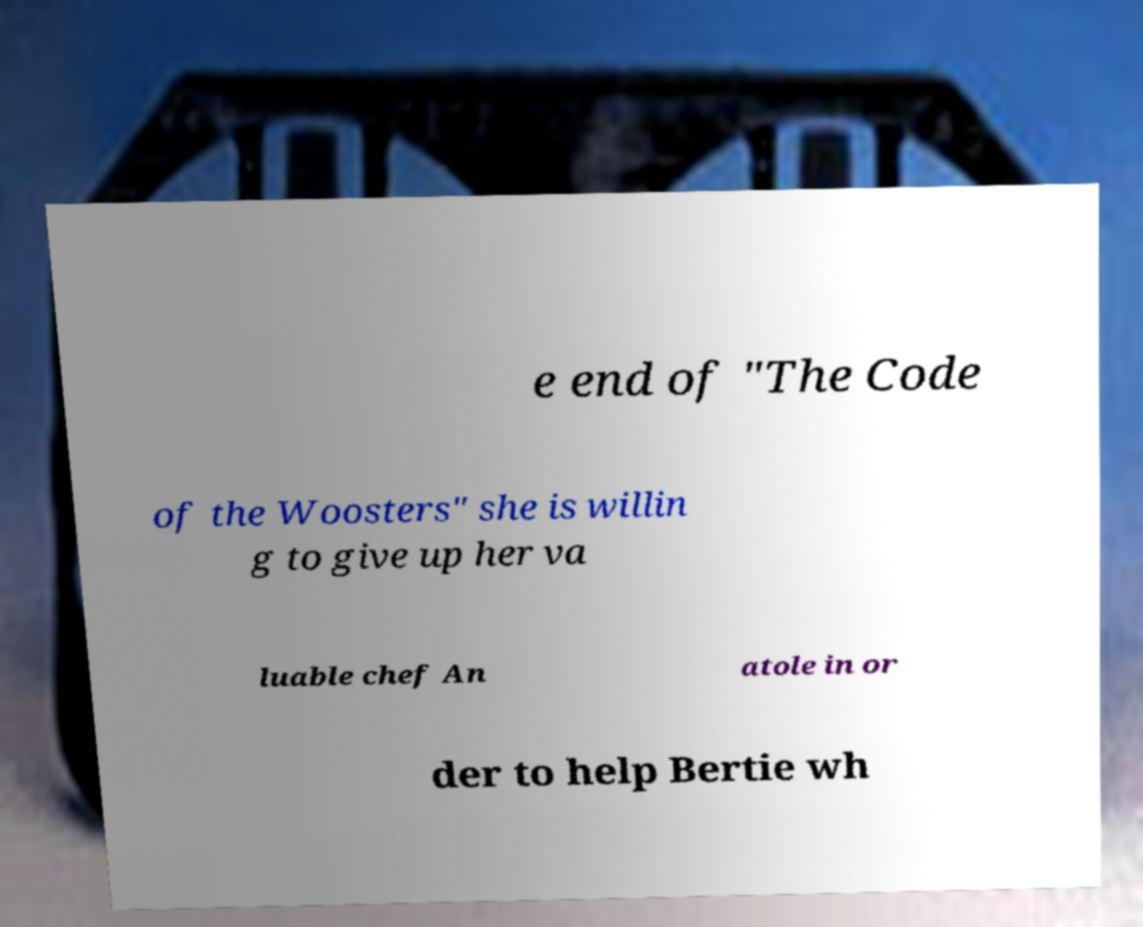Please identify and transcribe the text found in this image. e end of "The Code of the Woosters" she is willin g to give up her va luable chef An atole in or der to help Bertie wh 